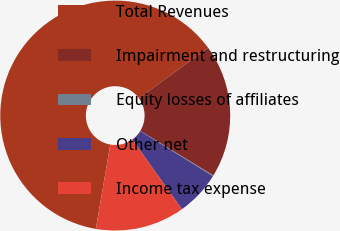<chart> <loc_0><loc_0><loc_500><loc_500><pie_chart><fcel>Total Revenues<fcel>Impairment and restructuring<fcel>Equity losses of affiliates<fcel>Other net<fcel>Income tax expense<nl><fcel>62.28%<fcel>18.76%<fcel>0.11%<fcel>6.32%<fcel>12.54%<nl></chart> 